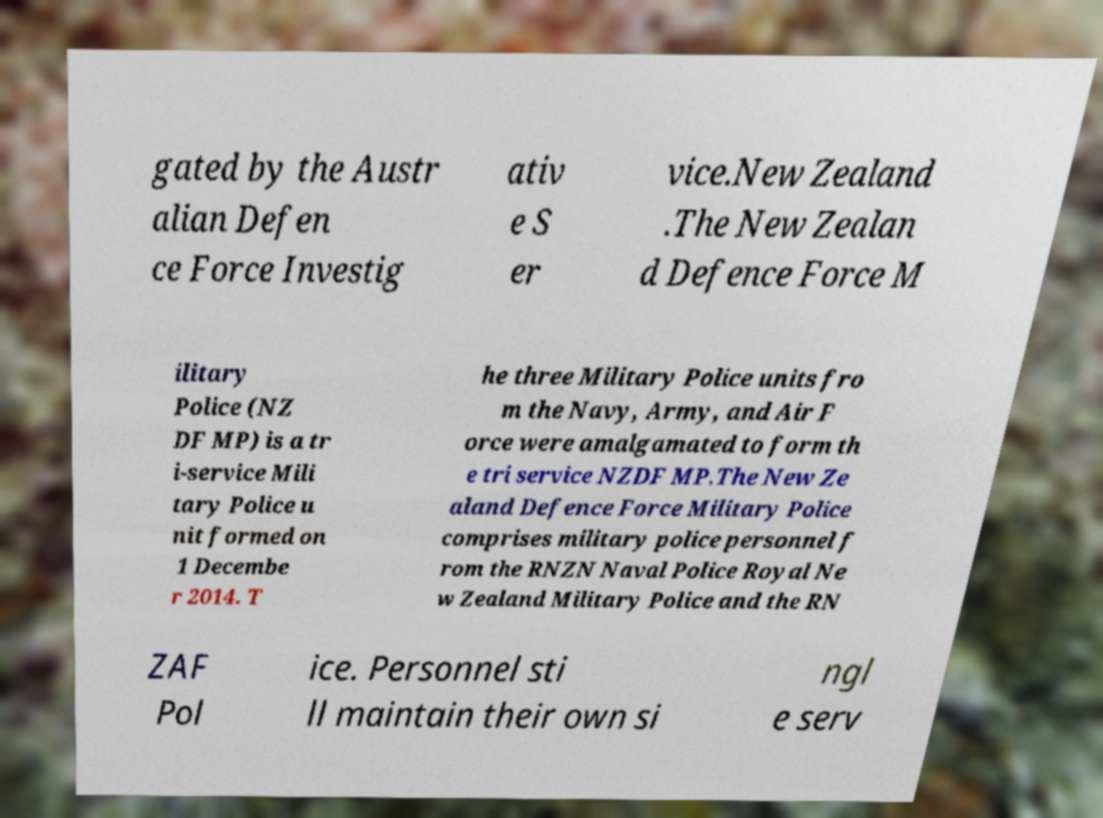For documentation purposes, I need the text within this image transcribed. Could you provide that? gated by the Austr alian Defen ce Force Investig ativ e S er vice.New Zealand .The New Zealan d Defence Force M ilitary Police (NZ DF MP) is a tr i-service Mili tary Police u nit formed on 1 Decembe r 2014. T he three Military Police units fro m the Navy, Army, and Air F orce were amalgamated to form th e tri service NZDF MP.The New Ze aland Defence Force Military Police comprises military police personnel f rom the RNZN Naval Police Royal Ne w Zealand Military Police and the RN ZAF Pol ice. Personnel sti ll maintain their own si ngl e serv 